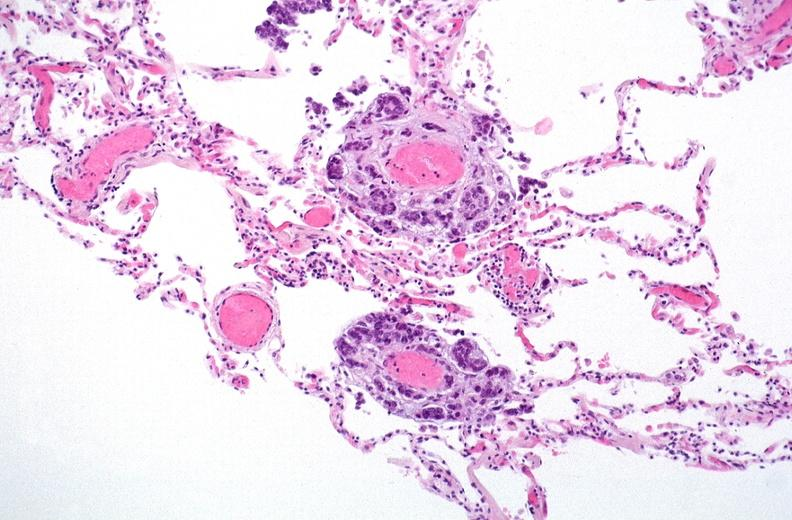where is this?
Answer the question using a single word or phrase. Lung 